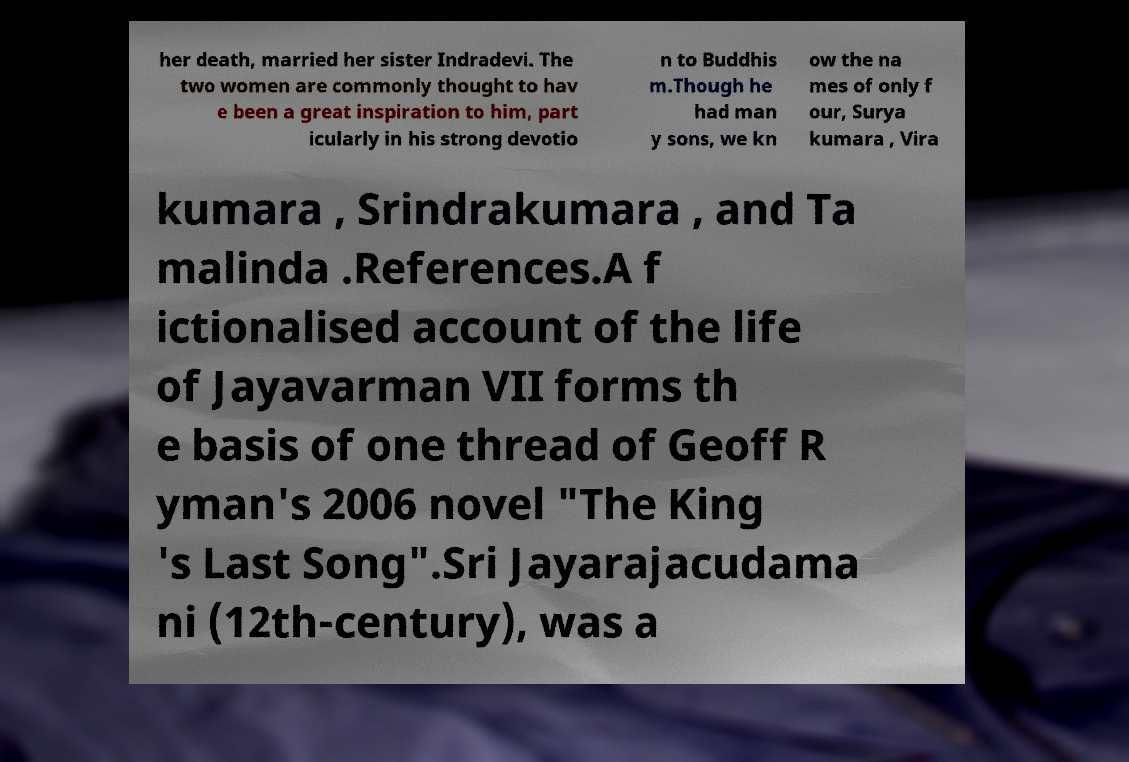Can you read and provide the text displayed in the image?This photo seems to have some interesting text. Can you extract and type it out for me? her death, married her sister Indradevi. The two women are commonly thought to hav e been a great inspiration to him, part icularly in his strong devotio n to Buddhis m.Though he had man y sons, we kn ow the na mes of only f our, Surya kumara , Vira kumara , Srindrakumara , and Ta malinda .References.A f ictionalised account of the life of Jayavarman VII forms th e basis of one thread of Geoff R yman's 2006 novel "The King 's Last Song".Sri Jayarajacudama ni (12th-century), was a 